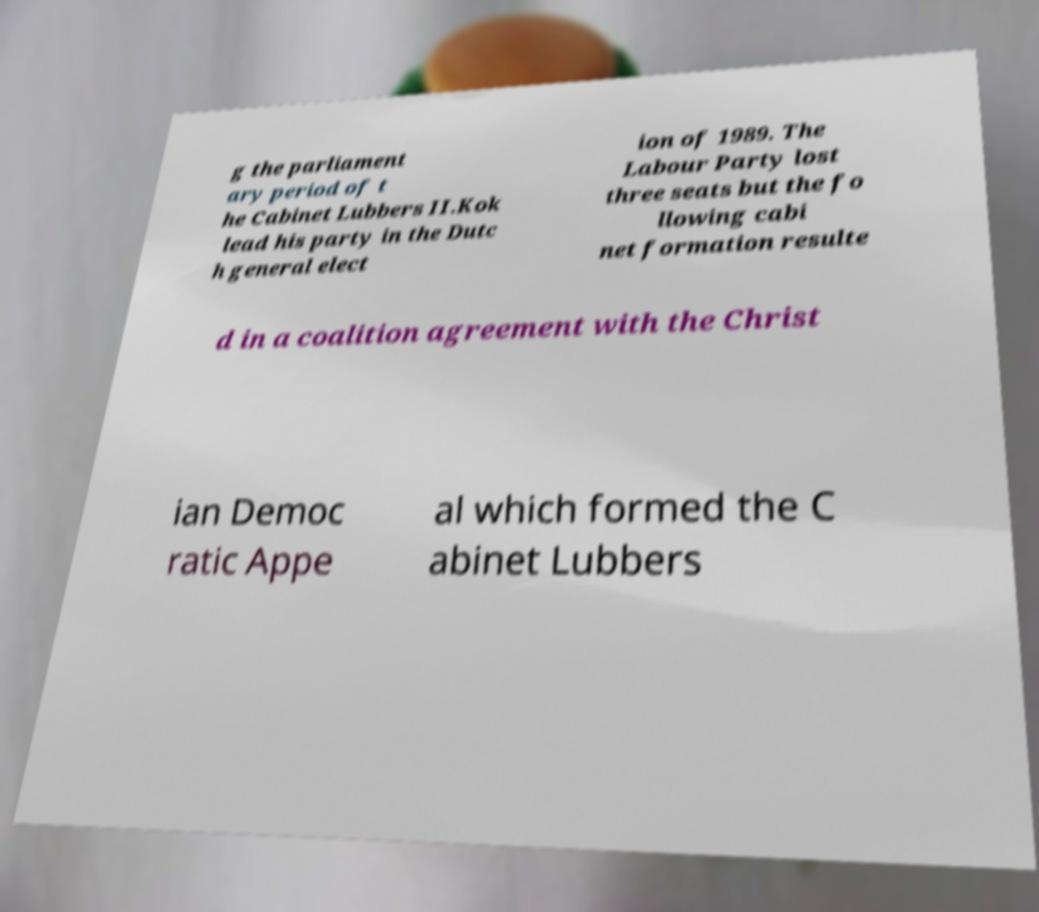For documentation purposes, I need the text within this image transcribed. Could you provide that? g the parliament ary period of t he Cabinet Lubbers II.Kok lead his party in the Dutc h general elect ion of 1989. The Labour Party lost three seats but the fo llowing cabi net formation resulte d in a coalition agreement with the Christ ian Democ ratic Appe al which formed the C abinet Lubbers 